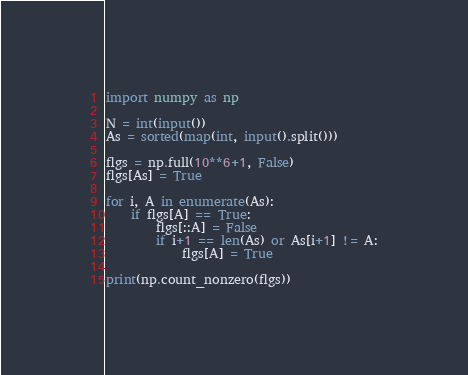Convert code to text. <code><loc_0><loc_0><loc_500><loc_500><_Python_>import numpy as np

N = int(input())
As = sorted(map(int, input().split()))

flgs = np.full(10**6+1, False)
flgs[As] = True

for i, A in enumerate(As):
    if flgs[A] == True:
        flgs[::A] = False
        if i+1 == len(As) or As[i+1] != A:
            flgs[A] = True

print(np.count_nonzero(flgs))</code> 